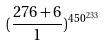<formula> <loc_0><loc_0><loc_500><loc_500>( \frac { 2 7 6 + 6 } { 1 } ) ^ { 4 5 0 ^ { 2 3 3 } }</formula> 